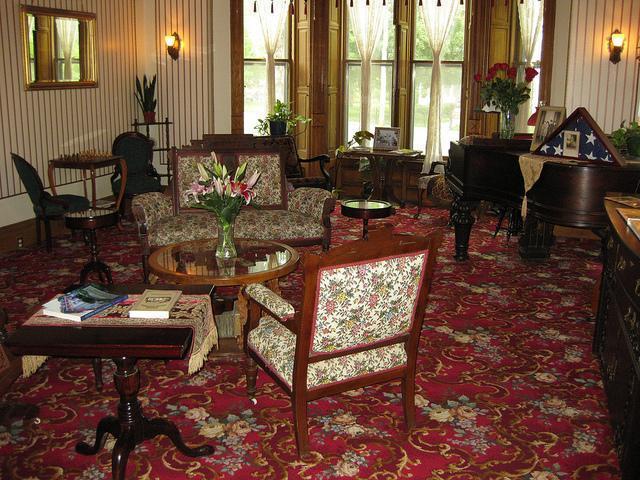How many chairs are in the picture?
Give a very brief answer. 4. How many people are holding camera?
Give a very brief answer. 0. 